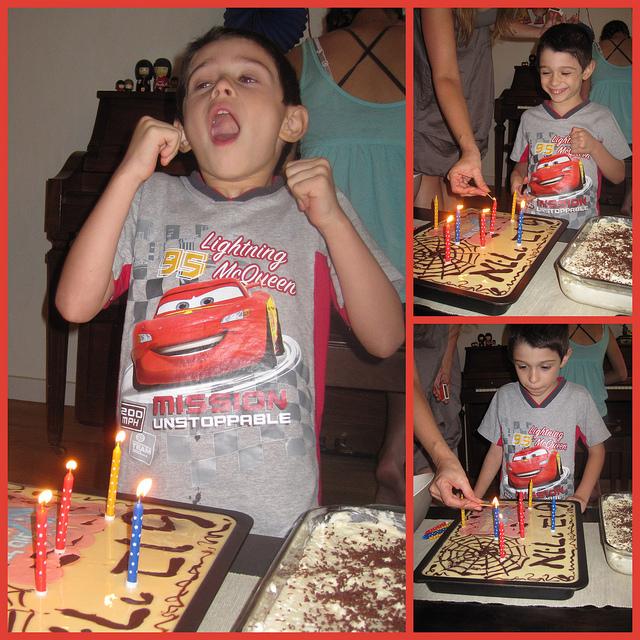What is he celebrating?
Keep it brief. Birthday. Is this kid about to sneeze?
Answer briefly. No. What picture is on the Kid's shirt?
Give a very brief answer. Car. 